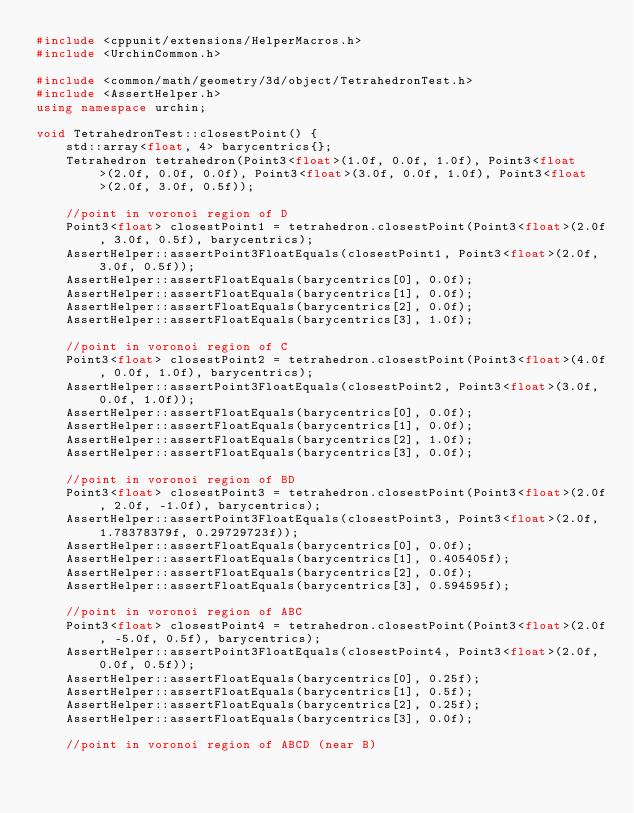Convert code to text. <code><loc_0><loc_0><loc_500><loc_500><_C++_>#include <cppunit/extensions/HelperMacros.h>
#include <UrchinCommon.h>

#include <common/math/geometry/3d/object/TetrahedronTest.h>
#include <AssertHelper.h>
using namespace urchin;

void TetrahedronTest::closestPoint() {
    std::array<float, 4> barycentrics{};
    Tetrahedron tetrahedron(Point3<float>(1.0f, 0.0f, 1.0f), Point3<float>(2.0f, 0.0f, 0.0f), Point3<float>(3.0f, 0.0f, 1.0f), Point3<float>(2.0f, 3.0f, 0.5f));

    //point in voronoi region of D
    Point3<float> closestPoint1 = tetrahedron.closestPoint(Point3<float>(2.0f, 3.0f, 0.5f), barycentrics);
    AssertHelper::assertPoint3FloatEquals(closestPoint1, Point3<float>(2.0f, 3.0f, 0.5f));
    AssertHelper::assertFloatEquals(barycentrics[0], 0.0f);
    AssertHelper::assertFloatEquals(barycentrics[1], 0.0f);
    AssertHelper::assertFloatEquals(barycentrics[2], 0.0f);
    AssertHelper::assertFloatEquals(barycentrics[3], 1.0f);

    //point in voronoi region of C
    Point3<float> closestPoint2 = tetrahedron.closestPoint(Point3<float>(4.0f, 0.0f, 1.0f), barycentrics);
    AssertHelper::assertPoint3FloatEquals(closestPoint2, Point3<float>(3.0f, 0.0f, 1.0f));
    AssertHelper::assertFloatEquals(barycentrics[0], 0.0f);
    AssertHelper::assertFloatEquals(barycentrics[1], 0.0f);
    AssertHelper::assertFloatEquals(barycentrics[2], 1.0f);
    AssertHelper::assertFloatEquals(barycentrics[3], 0.0f);

    //point in voronoi region of BD
    Point3<float> closestPoint3 = tetrahedron.closestPoint(Point3<float>(2.0f, 2.0f, -1.0f), barycentrics);
    AssertHelper::assertPoint3FloatEquals(closestPoint3, Point3<float>(2.0f, 1.78378379f, 0.29729723f));
    AssertHelper::assertFloatEquals(barycentrics[0], 0.0f);
    AssertHelper::assertFloatEquals(barycentrics[1], 0.405405f);
    AssertHelper::assertFloatEquals(barycentrics[2], 0.0f);
    AssertHelper::assertFloatEquals(barycentrics[3], 0.594595f);

    //point in voronoi region of ABC
    Point3<float> closestPoint4 = tetrahedron.closestPoint(Point3<float>(2.0f, -5.0f, 0.5f), barycentrics);
    AssertHelper::assertPoint3FloatEquals(closestPoint4, Point3<float>(2.0f, 0.0f, 0.5f));
    AssertHelper::assertFloatEquals(barycentrics[0], 0.25f);
    AssertHelper::assertFloatEquals(barycentrics[1], 0.5f);
    AssertHelper::assertFloatEquals(barycentrics[2], 0.25f);
    AssertHelper::assertFloatEquals(barycentrics[3], 0.0f);

    //point in voronoi region of ABCD (near B)</code> 